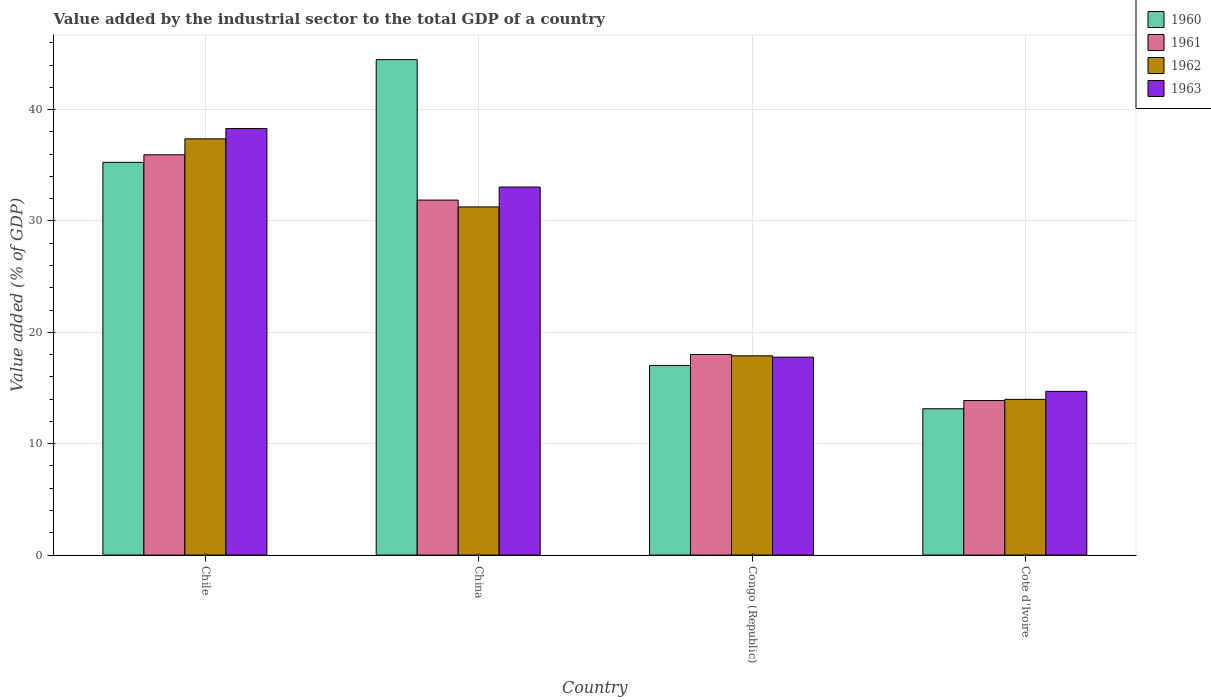How many different coloured bars are there?
Give a very brief answer. 4. How many groups of bars are there?
Offer a terse response. 4. Are the number of bars per tick equal to the number of legend labels?
Provide a short and direct response. Yes. Are the number of bars on each tick of the X-axis equal?
Your answer should be very brief. Yes. How many bars are there on the 4th tick from the left?
Provide a succinct answer. 4. How many bars are there on the 4th tick from the right?
Offer a very short reply. 4. What is the label of the 3rd group of bars from the left?
Your answer should be very brief. Congo (Republic). In how many cases, is the number of bars for a given country not equal to the number of legend labels?
Your response must be concise. 0. What is the value added by the industrial sector to the total GDP in 1963 in Cote d'Ivoire?
Your answer should be very brief. 14.7. Across all countries, what is the maximum value added by the industrial sector to the total GDP in 1962?
Provide a succinct answer. 37.38. Across all countries, what is the minimum value added by the industrial sector to the total GDP in 1960?
Give a very brief answer. 13.14. In which country was the value added by the industrial sector to the total GDP in 1961 minimum?
Keep it short and to the point. Cote d'Ivoire. What is the total value added by the industrial sector to the total GDP in 1963 in the graph?
Provide a short and direct response. 103.83. What is the difference between the value added by the industrial sector to the total GDP in 1960 in China and that in Congo (Republic)?
Give a very brief answer. 27.46. What is the difference between the value added by the industrial sector to the total GDP in 1962 in Chile and the value added by the industrial sector to the total GDP in 1963 in Congo (Republic)?
Offer a very short reply. 19.6. What is the average value added by the industrial sector to the total GDP in 1963 per country?
Your answer should be very brief. 25.96. What is the difference between the value added by the industrial sector to the total GDP of/in 1963 and value added by the industrial sector to the total GDP of/in 1961 in Chile?
Give a very brief answer. 2.36. What is the ratio of the value added by the industrial sector to the total GDP in 1963 in Congo (Republic) to that in Cote d'Ivoire?
Your answer should be very brief. 1.21. What is the difference between the highest and the second highest value added by the industrial sector to the total GDP in 1961?
Your response must be concise. -17.93. What is the difference between the highest and the lowest value added by the industrial sector to the total GDP in 1960?
Your response must be concise. 31.35. In how many countries, is the value added by the industrial sector to the total GDP in 1963 greater than the average value added by the industrial sector to the total GDP in 1963 taken over all countries?
Keep it short and to the point. 2. Is it the case that in every country, the sum of the value added by the industrial sector to the total GDP in 1960 and value added by the industrial sector to the total GDP in 1962 is greater than the sum of value added by the industrial sector to the total GDP in 1963 and value added by the industrial sector to the total GDP in 1961?
Make the answer very short. No. What does the 3rd bar from the right in Congo (Republic) represents?
Your response must be concise. 1961. Is it the case that in every country, the sum of the value added by the industrial sector to the total GDP in 1961 and value added by the industrial sector to the total GDP in 1962 is greater than the value added by the industrial sector to the total GDP in 1963?
Provide a succinct answer. Yes. How many bars are there?
Ensure brevity in your answer.  16. Are all the bars in the graph horizontal?
Offer a terse response. No. What is the difference between two consecutive major ticks on the Y-axis?
Your response must be concise. 10. Where does the legend appear in the graph?
Offer a very short reply. Top right. What is the title of the graph?
Offer a very short reply. Value added by the industrial sector to the total GDP of a country. What is the label or title of the Y-axis?
Provide a succinct answer. Value added (% of GDP). What is the Value added (% of GDP) of 1960 in Chile?
Offer a very short reply. 35.27. What is the Value added (% of GDP) of 1961 in Chile?
Your response must be concise. 35.94. What is the Value added (% of GDP) in 1962 in Chile?
Make the answer very short. 37.38. What is the Value added (% of GDP) in 1963 in Chile?
Give a very brief answer. 38.31. What is the Value added (% of GDP) in 1960 in China?
Offer a very short reply. 44.49. What is the Value added (% of GDP) in 1961 in China?
Make the answer very short. 31.88. What is the Value added (% of GDP) in 1962 in China?
Give a very brief answer. 31.26. What is the Value added (% of GDP) of 1963 in China?
Your answer should be compact. 33.05. What is the Value added (% of GDP) of 1960 in Congo (Republic)?
Offer a very short reply. 17.03. What is the Value added (% of GDP) in 1961 in Congo (Republic)?
Make the answer very short. 18.01. What is the Value added (% of GDP) of 1962 in Congo (Republic)?
Provide a short and direct response. 17.89. What is the Value added (% of GDP) of 1963 in Congo (Republic)?
Offer a terse response. 17.77. What is the Value added (% of GDP) of 1960 in Cote d'Ivoire?
Provide a succinct answer. 13.14. What is the Value added (% of GDP) in 1961 in Cote d'Ivoire?
Offer a very short reply. 13.88. What is the Value added (% of GDP) in 1962 in Cote d'Ivoire?
Provide a short and direct response. 13.98. What is the Value added (% of GDP) of 1963 in Cote d'Ivoire?
Make the answer very short. 14.7. Across all countries, what is the maximum Value added (% of GDP) of 1960?
Your answer should be compact. 44.49. Across all countries, what is the maximum Value added (% of GDP) of 1961?
Keep it short and to the point. 35.94. Across all countries, what is the maximum Value added (% of GDP) in 1962?
Offer a very short reply. 37.38. Across all countries, what is the maximum Value added (% of GDP) in 1963?
Keep it short and to the point. 38.31. Across all countries, what is the minimum Value added (% of GDP) of 1960?
Keep it short and to the point. 13.14. Across all countries, what is the minimum Value added (% of GDP) in 1961?
Provide a succinct answer. 13.88. Across all countries, what is the minimum Value added (% of GDP) in 1962?
Provide a succinct answer. 13.98. Across all countries, what is the minimum Value added (% of GDP) of 1963?
Make the answer very short. 14.7. What is the total Value added (% of GDP) of 1960 in the graph?
Ensure brevity in your answer.  109.92. What is the total Value added (% of GDP) of 1961 in the graph?
Provide a succinct answer. 99.71. What is the total Value added (% of GDP) of 1962 in the graph?
Your answer should be very brief. 100.51. What is the total Value added (% of GDP) in 1963 in the graph?
Ensure brevity in your answer.  103.83. What is the difference between the Value added (% of GDP) of 1960 in Chile and that in China?
Offer a very short reply. -9.22. What is the difference between the Value added (% of GDP) in 1961 in Chile and that in China?
Offer a very short reply. 4.07. What is the difference between the Value added (% of GDP) of 1962 in Chile and that in China?
Your response must be concise. 6.11. What is the difference between the Value added (% of GDP) of 1963 in Chile and that in China?
Give a very brief answer. 5.26. What is the difference between the Value added (% of GDP) of 1960 in Chile and that in Congo (Republic)?
Provide a succinct answer. 18.24. What is the difference between the Value added (% of GDP) of 1961 in Chile and that in Congo (Republic)?
Make the answer very short. 17.93. What is the difference between the Value added (% of GDP) of 1962 in Chile and that in Congo (Republic)?
Your answer should be very brief. 19.48. What is the difference between the Value added (% of GDP) of 1963 in Chile and that in Congo (Republic)?
Your answer should be very brief. 20.54. What is the difference between the Value added (% of GDP) of 1960 in Chile and that in Cote d'Ivoire?
Keep it short and to the point. 22.13. What is the difference between the Value added (% of GDP) of 1961 in Chile and that in Cote d'Ivoire?
Give a very brief answer. 22.06. What is the difference between the Value added (% of GDP) of 1962 in Chile and that in Cote d'Ivoire?
Keep it short and to the point. 23.39. What is the difference between the Value added (% of GDP) in 1963 in Chile and that in Cote d'Ivoire?
Ensure brevity in your answer.  23.61. What is the difference between the Value added (% of GDP) in 1960 in China and that in Congo (Republic)?
Provide a short and direct response. 27.46. What is the difference between the Value added (% of GDP) in 1961 in China and that in Congo (Republic)?
Provide a short and direct response. 13.87. What is the difference between the Value added (% of GDP) of 1962 in China and that in Congo (Republic)?
Keep it short and to the point. 13.37. What is the difference between the Value added (% of GDP) of 1963 in China and that in Congo (Republic)?
Give a very brief answer. 15.28. What is the difference between the Value added (% of GDP) of 1960 in China and that in Cote d'Ivoire?
Keep it short and to the point. 31.35. What is the difference between the Value added (% of GDP) in 1961 in China and that in Cote d'Ivoire?
Your answer should be very brief. 18. What is the difference between the Value added (% of GDP) of 1962 in China and that in Cote d'Ivoire?
Give a very brief answer. 17.28. What is the difference between the Value added (% of GDP) in 1963 in China and that in Cote d'Ivoire?
Your answer should be very brief. 18.35. What is the difference between the Value added (% of GDP) in 1960 in Congo (Republic) and that in Cote d'Ivoire?
Your answer should be compact. 3.89. What is the difference between the Value added (% of GDP) in 1961 in Congo (Republic) and that in Cote d'Ivoire?
Your answer should be compact. 4.13. What is the difference between the Value added (% of GDP) of 1962 in Congo (Republic) and that in Cote d'Ivoire?
Offer a terse response. 3.91. What is the difference between the Value added (% of GDP) of 1963 in Congo (Republic) and that in Cote d'Ivoire?
Your answer should be very brief. 3.07. What is the difference between the Value added (% of GDP) in 1960 in Chile and the Value added (% of GDP) in 1961 in China?
Offer a very short reply. 3.39. What is the difference between the Value added (% of GDP) in 1960 in Chile and the Value added (% of GDP) in 1962 in China?
Keep it short and to the point. 4. What is the difference between the Value added (% of GDP) of 1960 in Chile and the Value added (% of GDP) of 1963 in China?
Offer a very short reply. 2.22. What is the difference between the Value added (% of GDP) of 1961 in Chile and the Value added (% of GDP) of 1962 in China?
Offer a very short reply. 4.68. What is the difference between the Value added (% of GDP) in 1961 in Chile and the Value added (% of GDP) in 1963 in China?
Your answer should be compact. 2.89. What is the difference between the Value added (% of GDP) in 1962 in Chile and the Value added (% of GDP) in 1963 in China?
Make the answer very short. 4.33. What is the difference between the Value added (% of GDP) in 1960 in Chile and the Value added (% of GDP) in 1961 in Congo (Republic)?
Provide a succinct answer. 17.26. What is the difference between the Value added (% of GDP) in 1960 in Chile and the Value added (% of GDP) in 1962 in Congo (Republic)?
Your answer should be compact. 17.37. What is the difference between the Value added (% of GDP) of 1960 in Chile and the Value added (% of GDP) of 1963 in Congo (Republic)?
Your answer should be very brief. 17.49. What is the difference between the Value added (% of GDP) in 1961 in Chile and the Value added (% of GDP) in 1962 in Congo (Republic)?
Make the answer very short. 18.05. What is the difference between the Value added (% of GDP) of 1961 in Chile and the Value added (% of GDP) of 1963 in Congo (Republic)?
Provide a succinct answer. 18.17. What is the difference between the Value added (% of GDP) in 1962 in Chile and the Value added (% of GDP) in 1963 in Congo (Republic)?
Your answer should be very brief. 19.6. What is the difference between the Value added (% of GDP) of 1960 in Chile and the Value added (% of GDP) of 1961 in Cote d'Ivoire?
Offer a very short reply. 21.39. What is the difference between the Value added (% of GDP) in 1960 in Chile and the Value added (% of GDP) in 1962 in Cote d'Ivoire?
Give a very brief answer. 21.28. What is the difference between the Value added (% of GDP) of 1960 in Chile and the Value added (% of GDP) of 1963 in Cote d'Ivoire?
Provide a short and direct response. 20.57. What is the difference between the Value added (% of GDP) of 1961 in Chile and the Value added (% of GDP) of 1962 in Cote d'Ivoire?
Make the answer very short. 21.96. What is the difference between the Value added (% of GDP) of 1961 in Chile and the Value added (% of GDP) of 1963 in Cote d'Ivoire?
Offer a very short reply. 21.24. What is the difference between the Value added (% of GDP) in 1962 in Chile and the Value added (% of GDP) in 1963 in Cote d'Ivoire?
Offer a terse response. 22.68. What is the difference between the Value added (% of GDP) in 1960 in China and the Value added (% of GDP) in 1961 in Congo (Republic)?
Offer a very short reply. 26.48. What is the difference between the Value added (% of GDP) in 1960 in China and the Value added (% of GDP) in 1962 in Congo (Republic)?
Ensure brevity in your answer.  26.6. What is the difference between the Value added (% of GDP) of 1960 in China and the Value added (% of GDP) of 1963 in Congo (Republic)?
Offer a very short reply. 26.72. What is the difference between the Value added (% of GDP) in 1961 in China and the Value added (% of GDP) in 1962 in Congo (Republic)?
Your answer should be very brief. 13.98. What is the difference between the Value added (% of GDP) in 1961 in China and the Value added (% of GDP) in 1963 in Congo (Republic)?
Offer a terse response. 14.1. What is the difference between the Value added (% of GDP) in 1962 in China and the Value added (% of GDP) in 1963 in Congo (Republic)?
Make the answer very short. 13.49. What is the difference between the Value added (% of GDP) of 1960 in China and the Value added (% of GDP) of 1961 in Cote d'Ivoire?
Make the answer very short. 30.61. What is the difference between the Value added (% of GDP) of 1960 in China and the Value added (% of GDP) of 1962 in Cote d'Ivoire?
Provide a succinct answer. 30.51. What is the difference between the Value added (% of GDP) in 1960 in China and the Value added (% of GDP) in 1963 in Cote d'Ivoire?
Your response must be concise. 29.79. What is the difference between the Value added (% of GDP) of 1961 in China and the Value added (% of GDP) of 1962 in Cote d'Ivoire?
Your response must be concise. 17.9. What is the difference between the Value added (% of GDP) in 1961 in China and the Value added (% of GDP) in 1963 in Cote d'Ivoire?
Your response must be concise. 17.18. What is the difference between the Value added (% of GDP) of 1962 in China and the Value added (% of GDP) of 1963 in Cote d'Ivoire?
Offer a very short reply. 16.56. What is the difference between the Value added (% of GDP) of 1960 in Congo (Republic) and the Value added (% of GDP) of 1961 in Cote d'Ivoire?
Provide a succinct answer. 3.15. What is the difference between the Value added (% of GDP) in 1960 in Congo (Republic) and the Value added (% of GDP) in 1962 in Cote d'Ivoire?
Your response must be concise. 3.05. What is the difference between the Value added (% of GDP) of 1960 in Congo (Republic) and the Value added (% of GDP) of 1963 in Cote d'Ivoire?
Offer a terse response. 2.33. What is the difference between the Value added (% of GDP) in 1961 in Congo (Republic) and the Value added (% of GDP) in 1962 in Cote d'Ivoire?
Keep it short and to the point. 4.03. What is the difference between the Value added (% of GDP) of 1961 in Congo (Republic) and the Value added (% of GDP) of 1963 in Cote d'Ivoire?
Ensure brevity in your answer.  3.31. What is the difference between the Value added (% of GDP) of 1962 in Congo (Republic) and the Value added (% of GDP) of 1963 in Cote d'Ivoire?
Offer a terse response. 3.19. What is the average Value added (% of GDP) in 1960 per country?
Your answer should be compact. 27.48. What is the average Value added (% of GDP) in 1961 per country?
Give a very brief answer. 24.93. What is the average Value added (% of GDP) in 1962 per country?
Your answer should be very brief. 25.13. What is the average Value added (% of GDP) in 1963 per country?
Give a very brief answer. 25.96. What is the difference between the Value added (% of GDP) in 1960 and Value added (% of GDP) in 1961 in Chile?
Keep it short and to the point. -0.68. What is the difference between the Value added (% of GDP) of 1960 and Value added (% of GDP) of 1962 in Chile?
Keep it short and to the point. -2.11. What is the difference between the Value added (% of GDP) of 1960 and Value added (% of GDP) of 1963 in Chile?
Your answer should be very brief. -3.04. What is the difference between the Value added (% of GDP) in 1961 and Value added (% of GDP) in 1962 in Chile?
Your response must be concise. -1.43. What is the difference between the Value added (% of GDP) of 1961 and Value added (% of GDP) of 1963 in Chile?
Your answer should be compact. -2.36. What is the difference between the Value added (% of GDP) of 1962 and Value added (% of GDP) of 1963 in Chile?
Your response must be concise. -0.93. What is the difference between the Value added (% of GDP) of 1960 and Value added (% of GDP) of 1961 in China?
Provide a short and direct response. 12.61. What is the difference between the Value added (% of GDP) of 1960 and Value added (% of GDP) of 1962 in China?
Give a very brief answer. 13.23. What is the difference between the Value added (% of GDP) in 1960 and Value added (% of GDP) in 1963 in China?
Your response must be concise. 11.44. What is the difference between the Value added (% of GDP) of 1961 and Value added (% of GDP) of 1962 in China?
Offer a very short reply. 0.61. What is the difference between the Value added (% of GDP) of 1961 and Value added (% of GDP) of 1963 in China?
Your answer should be compact. -1.17. What is the difference between the Value added (% of GDP) of 1962 and Value added (% of GDP) of 1963 in China?
Offer a terse response. -1.79. What is the difference between the Value added (% of GDP) of 1960 and Value added (% of GDP) of 1961 in Congo (Republic)?
Make the answer very short. -0.98. What is the difference between the Value added (% of GDP) in 1960 and Value added (% of GDP) in 1962 in Congo (Republic)?
Make the answer very short. -0.86. What is the difference between the Value added (% of GDP) in 1960 and Value added (% of GDP) in 1963 in Congo (Republic)?
Make the answer very short. -0.74. What is the difference between the Value added (% of GDP) of 1961 and Value added (% of GDP) of 1962 in Congo (Republic)?
Your answer should be compact. 0.12. What is the difference between the Value added (% of GDP) of 1961 and Value added (% of GDP) of 1963 in Congo (Republic)?
Your response must be concise. 0.24. What is the difference between the Value added (% of GDP) of 1962 and Value added (% of GDP) of 1963 in Congo (Republic)?
Your response must be concise. 0.12. What is the difference between the Value added (% of GDP) in 1960 and Value added (% of GDP) in 1961 in Cote d'Ivoire?
Provide a succinct answer. -0.74. What is the difference between the Value added (% of GDP) of 1960 and Value added (% of GDP) of 1962 in Cote d'Ivoire?
Keep it short and to the point. -0.84. What is the difference between the Value added (% of GDP) in 1960 and Value added (% of GDP) in 1963 in Cote d'Ivoire?
Offer a very short reply. -1.56. What is the difference between the Value added (% of GDP) of 1961 and Value added (% of GDP) of 1962 in Cote d'Ivoire?
Make the answer very short. -0.1. What is the difference between the Value added (% of GDP) of 1961 and Value added (% of GDP) of 1963 in Cote d'Ivoire?
Provide a succinct answer. -0.82. What is the difference between the Value added (% of GDP) in 1962 and Value added (% of GDP) in 1963 in Cote d'Ivoire?
Ensure brevity in your answer.  -0.72. What is the ratio of the Value added (% of GDP) of 1960 in Chile to that in China?
Your response must be concise. 0.79. What is the ratio of the Value added (% of GDP) of 1961 in Chile to that in China?
Ensure brevity in your answer.  1.13. What is the ratio of the Value added (% of GDP) of 1962 in Chile to that in China?
Offer a terse response. 1.2. What is the ratio of the Value added (% of GDP) of 1963 in Chile to that in China?
Offer a very short reply. 1.16. What is the ratio of the Value added (% of GDP) in 1960 in Chile to that in Congo (Republic)?
Your response must be concise. 2.07. What is the ratio of the Value added (% of GDP) in 1961 in Chile to that in Congo (Republic)?
Ensure brevity in your answer.  2. What is the ratio of the Value added (% of GDP) of 1962 in Chile to that in Congo (Republic)?
Your answer should be very brief. 2.09. What is the ratio of the Value added (% of GDP) of 1963 in Chile to that in Congo (Republic)?
Your answer should be compact. 2.16. What is the ratio of the Value added (% of GDP) of 1960 in Chile to that in Cote d'Ivoire?
Offer a very short reply. 2.68. What is the ratio of the Value added (% of GDP) in 1961 in Chile to that in Cote d'Ivoire?
Keep it short and to the point. 2.59. What is the ratio of the Value added (% of GDP) in 1962 in Chile to that in Cote d'Ivoire?
Your answer should be compact. 2.67. What is the ratio of the Value added (% of GDP) of 1963 in Chile to that in Cote d'Ivoire?
Offer a very short reply. 2.61. What is the ratio of the Value added (% of GDP) in 1960 in China to that in Congo (Republic)?
Your answer should be very brief. 2.61. What is the ratio of the Value added (% of GDP) in 1961 in China to that in Congo (Republic)?
Offer a terse response. 1.77. What is the ratio of the Value added (% of GDP) of 1962 in China to that in Congo (Republic)?
Offer a very short reply. 1.75. What is the ratio of the Value added (% of GDP) of 1963 in China to that in Congo (Republic)?
Keep it short and to the point. 1.86. What is the ratio of the Value added (% of GDP) of 1960 in China to that in Cote d'Ivoire?
Your response must be concise. 3.39. What is the ratio of the Value added (% of GDP) in 1961 in China to that in Cote d'Ivoire?
Make the answer very short. 2.3. What is the ratio of the Value added (% of GDP) of 1962 in China to that in Cote d'Ivoire?
Ensure brevity in your answer.  2.24. What is the ratio of the Value added (% of GDP) in 1963 in China to that in Cote d'Ivoire?
Your response must be concise. 2.25. What is the ratio of the Value added (% of GDP) in 1960 in Congo (Republic) to that in Cote d'Ivoire?
Your answer should be compact. 1.3. What is the ratio of the Value added (% of GDP) of 1961 in Congo (Republic) to that in Cote d'Ivoire?
Make the answer very short. 1.3. What is the ratio of the Value added (% of GDP) of 1962 in Congo (Republic) to that in Cote d'Ivoire?
Your answer should be very brief. 1.28. What is the ratio of the Value added (% of GDP) of 1963 in Congo (Republic) to that in Cote d'Ivoire?
Ensure brevity in your answer.  1.21. What is the difference between the highest and the second highest Value added (% of GDP) of 1960?
Provide a succinct answer. 9.22. What is the difference between the highest and the second highest Value added (% of GDP) of 1961?
Your answer should be compact. 4.07. What is the difference between the highest and the second highest Value added (% of GDP) in 1962?
Give a very brief answer. 6.11. What is the difference between the highest and the second highest Value added (% of GDP) in 1963?
Keep it short and to the point. 5.26. What is the difference between the highest and the lowest Value added (% of GDP) of 1960?
Your answer should be compact. 31.35. What is the difference between the highest and the lowest Value added (% of GDP) in 1961?
Make the answer very short. 22.06. What is the difference between the highest and the lowest Value added (% of GDP) in 1962?
Provide a succinct answer. 23.39. What is the difference between the highest and the lowest Value added (% of GDP) of 1963?
Offer a terse response. 23.61. 